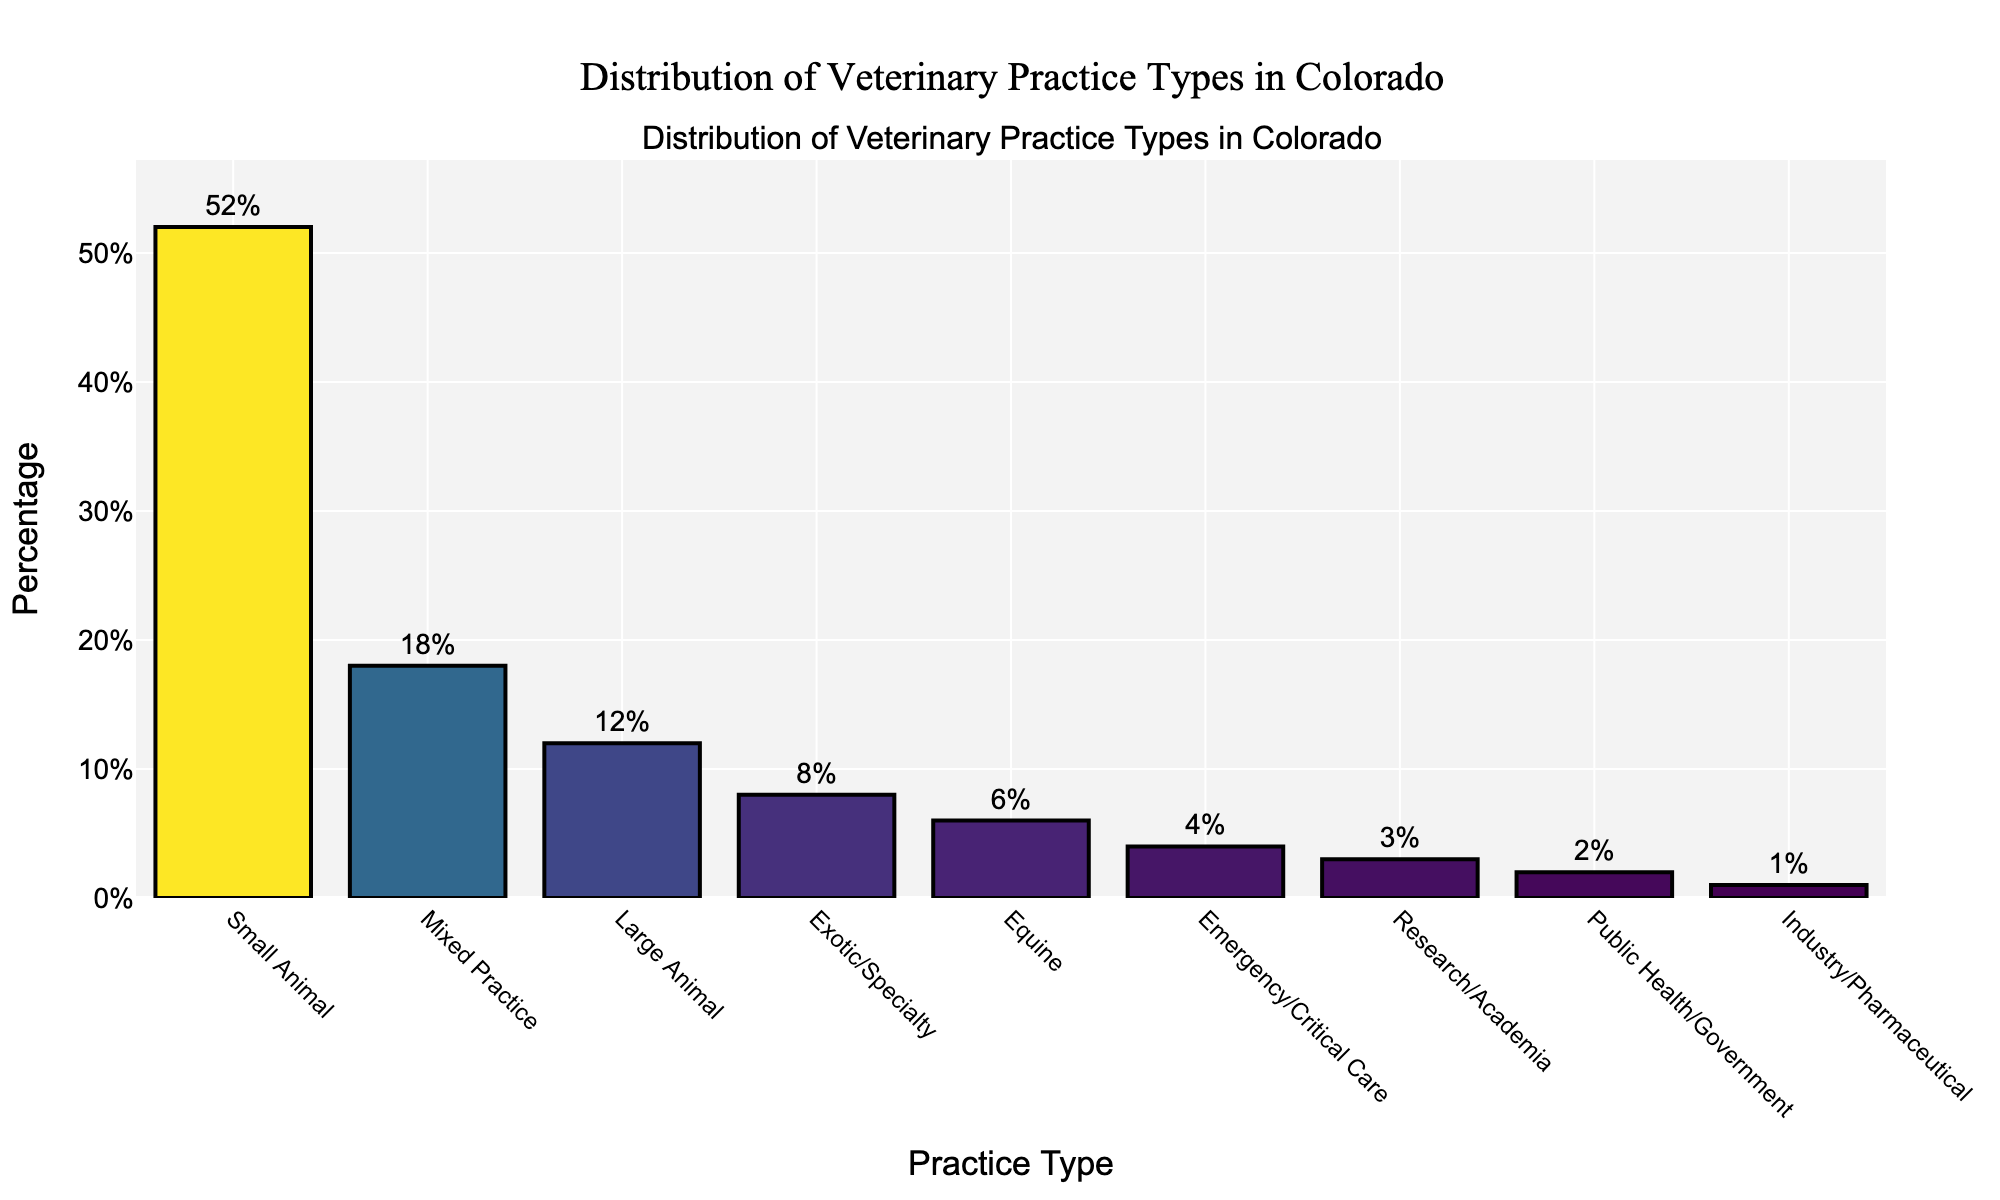Which practice type has the highest percentage? The bar representing 'Small Animal' is the tallest and reaches 52%, indicating it has the highest percentage.
Answer: Small Animal What is the combined percentage of Mixed Practice and Large Animal? According to the chart, Mixed Practice is 18% and Large Animal is 12%. Adding these together: 18% + 12% = 30%.
Answer: 30% How much greater is the percentage for Small Animal compared to Research/Academia? Small Animal is 52% while Research/Academia is 3%. The difference is 52% - 3% = 49%.
Answer: 49% Which practice type has the smallest percentage? The bar for Industry/Pharmaceutical is the shortest and reaches 1%, indicating it has the smallest percentage.
Answer: Industry/Pharmaceutical What is the average percentage of the top three practice types? The top three practice types are Small Animal (52%), Mixed Practice (18%), and Large Animal (12%). The sum of these percentages is 52% + 18% + 12% = 82%. The average is 82% / 3 = 27.33%.
Answer: 27.33% How many practice types have a percentage equal to or above 10%? By observing the bars, Small Animal (52%), Mixed Practice (18%), and Large Animal (12%) each have percentages equal to or above 10%. There are 3 such practice types.
Answer: 3 What is the difference between the percentage of Equine and Exotic/Specialty? Equine is at 6% and Exotic/Specialty is at 8%. The difference is 8% - 6% = 2%.
Answer: 2% Which practice type has a percentage closest to 5%? The bar for Equine closely matches 5%, which is actually 6%.
Answer: Equine What is the total percentage for the bottom five practice types? The bottom five practice types are Equine (6%), Emergency/Critical Care (4%), Research/Academia (3%), Public Health/Government (2%), and Industry/Pharmaceutical (1%). Adding these together: 6% + 4% + 3% + 2% + 1% = 16%.
Answer: 16% 